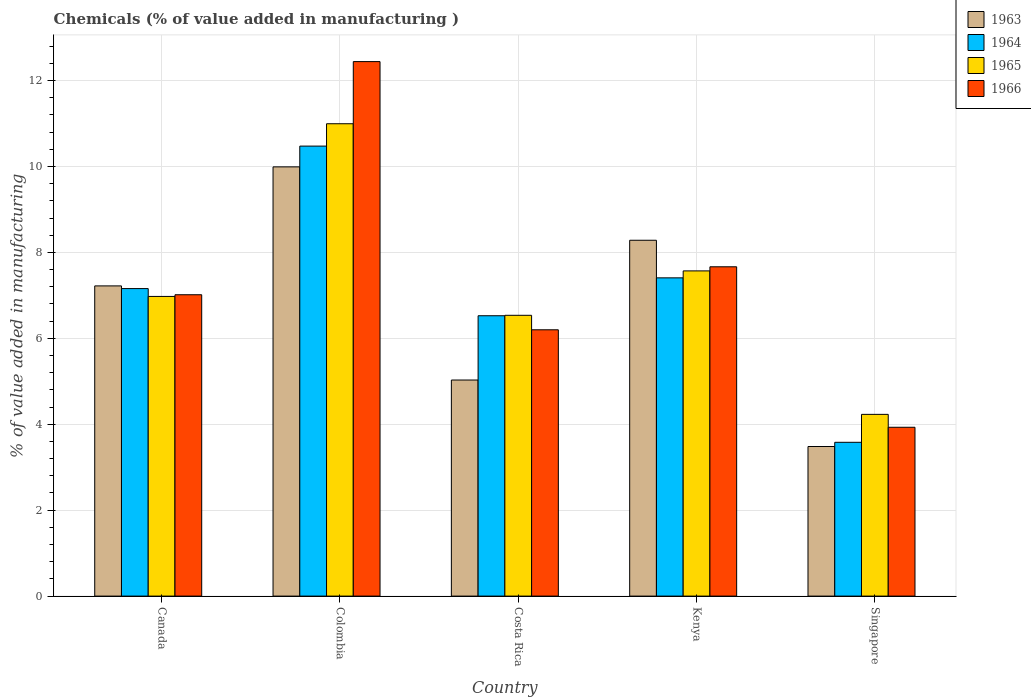Are the number of bars on each tick of the X-axis equal?
Keep it short and to the point. Yes. What is the label of the 1st group of bars from the left?
Your answer should be compact. Canada. What is the value added in manufacturing chemicals in 1964 in Canada?
Provide a succinct answer. 7.16. Across all countries, what is the maximum value added in manufacturing chemicals in 1963?
Give a very brief answer. 9.99. Across all countries, what is the minimum value added in manufacturing chemicals in 1965?
Give a very brief answer. 4.23. In which country was the value added in manufacturing chemicals in 1966 minimum?
Give a very brief answer. Singapore. What is the total value added in manufacturing chemicals in 1963 in the graph?
Ensure brevity in your answer.  34.01. What is the difference between the value added in manufacturing chemicals in 1964 in Costa Rica and that in Kenya?
Your answer should be compact. -0.88. What is the difference between the value added in manufacturing chemicals in 1964 in Colombia and the value added in manufacturing chemicals in 1965 in Singapore?
Your answer should be compact. 6.24. What is the average value added in manufacturing chemicals in 1966 per country?
Give a very brief answer. 7.45. What is the difference between the value added in manufacturing chemicals of/in 1966 and value added in manufacturing chemicals of/in 1963 in Singapore?
Provide a succinct answer. 0.45. What is the ratio of the value added in manufacturing chemicals in 1965 in Canada to that in Singapore?
Keep it short and to the point. 1.65. Is the value added in manufacturing chemicals in 1965 in Costa Rica less than that in Kenya?
Your response must be concise. Yes. What is the difference between the highest and the second highest value added in manufacturing chemicals in 1963?
Offer a very short reply. -1.71. What is the difference between the highest and the lowest value added in manufacturing chemicals in 1965?
Offer a very short reply. 6.76. Is the sum of the value added in manufacturing chemicals in 1963 in Costa Rica and Kenya greater than the maximum value added in manufacturing chemicals in 1966 across all countries?
Your answer should be very brief. Yes. Is it the case that in every country, the sum of the value added in manufacturing chemicals in 1963 and value added in manufacturing chemicals in 1966 is greater than the sum of value added in manufacturing chemicals in 1964 and value added in manufacturing chemicals in 1965?
Offer a terse response. No. What does the 4th bar from the left in Colombia represents?
Provide a succinct answer. 1966. What does the 1st bar from the right in Singapore represents?
Offer a very short reply. 1966. Is it the case that in every country, the sum of the value added in manufacturing chemicals in 1964 and value added in manufacturing chemicals in 1966 is greater than the value added in manufacturing chemicals in 1963?
Your answer should be compact. Yes. How many bars are there?
Offer a very short reply. 20. What is the difference between two consecutive major ticks on the Y-axis?
Provide a short and direct response. 2. Does the graph contain grids?
Offer a very short reply. Yes. How many legend labels are there?
Offer a terse response. 4. What is the title of the graph?
Keep it short and to the point. Chemicals (% of value added in manufacturing ). Does "1996" appear as one of the legend labels in the graph?
Keep it short and to the point. No. What is the label or title of the Y-axis?
Your response must be concise. % of value added in manufacturing. What is the % of value added in manufacturing in 1963 in Canada?
Provide a short and direct response. 7.22. What is the % of value added in manufacturing in 1964 in Canada?
Keep it short and to the point. 7.16. What is the % of value added in manufacturing of 1965 in Canada?
Give a very brief answer. 6.98. What is the % of value added in manufacturing of 1966 in Canada?
Provide a short and direct response. 7.01. What is the % of value added in manufacturing of 1963 in Colombia?
Ensure brevity in your answer.  9.99. What is the % of value added in manufacturing of 1964 in Colombia?
Offer a terse response. 10.47. What is the % of value added in manufacturing in 1965 in Colombia?
Your answer should be compact. 10.99. What is the % of value added in manufacturing of 1966 in Colombia?
Your answer should be compact. 12.44. What is the % of value added in manufacturing of 1963 in Costa Rica?
Ensure brevity in your answer.  5.03. What is the % of value added in manufacturing in 1964 in Costa Rica?
Give a very brief answer. 6.53. What is the % of value added in manufacturing of 1965 in Costa Rica?
Provide a short and direct response. 6.54. What is the % of value added in manufacturing in 1966 in Costa Rica?
Make the answer very short. 6.2. What is the % of value added in manufacturing in 1963 in Kenya?
Your answer should be compact. 8.28. What is the % of value added in manufacturing of 1964 in Kenya?
Your answer should be compact. 7.41. What is the % of value added in manufacturing of 1965 in Kenya?
Keep it short and to the point. 7.57. What is the % of value added in manufacturing in 1966 in Kenya?
Make the answer very short. 7.67. What is the % of value added in manufacturing in 1963 in Singapore?
Keep it short and to the point. 3.48. What is the % of value added in manufacturing of 1964 in Singapore?
Give a very brief answer. 3.58. What is the % of value added in manufacturing in 1965 in Singapore?
Make the answer very short. 4.23. What is the % of value added in manufacturing in 1966 in Singapore?
Offer a terse response. 3.93. Across all countries, what is the maximum % of value added in manufacturing of 1963?
Provide a short and direct response. 9.99. Across all countries, what is the maximum % of value added in manufacturing in 1964?
Make the answer very short. 10.47. Across all countries, what is the maximum % of value added in manufacturing of 1965?
Provide a succinct answer. 10.99. Across all countries, what is the maximum % of value added in manufacturing of 1966?
Offer a terse response. 12.44. Across all countries, what is the minimum % of value added in manufacturing of 1963?
Provide a short and direct response. 3.48. Across all countries, what is the minimum % of value added in manufacturing of 1964?
Offer a terse response. 3.58. Across all countries, what is the minimum % of value added in manufacturing of 1965?
Your response must be concise. 4.23. Across all countries, what is the minimum % of value added in manufacturing in 1966?
Your response must be concise. 3.93. What is the total % of value added in manufacturing in 1963 in the graph?
Provide a short and direct response. 34.01. What is the total % of value added in manufacturing of 1964 in the graph?
Ensure brevity in your answer.  35.15. What is the total % of value added in manufacturing in 1965 in the graph?
Your response must be concise. 36.31. What is the total % of value added in manufacturing in 1966 in the graph?
Offer a terse response. 37.25. What is the difference between the % of value added in manufacturing in 1963 in Canada and that in Colombia?
Ensure brevity in your answer.  -2.77. What is the difference between the % of value added in manufacturing in 1964 in Canada and that in Colombia?
Give a very brief answer. -3.32. What is the difference between the % of value added in manufacturing in 1965 in Canada and that in Colombia?
Offer a terse response. -4.02. What is the difference between the % of value added in manufacturing in 1966 in Canada and that in Colombia?
Keep it short and to the point. -5.43. What is the difference between the % of value added in manufacturing of 1963 in Canada and that in Costa Rica?
Offer a terse response. 2.19. What is the difference between the % of value added in manufacturing in 1964 in Canada and that in Costa Rica?
Keep it short and to the point. 0.63. What is the difference between the % of value added in manufacturing of 1965 in Canada and that in Costa Rica?
Make the answer very short. 0.44. What is the difference between the % of value added in manufacturing in 1966 in Canada and that in Costa Rica?
Your answer should be compact. 0.82. What is the difference between the % of value added in manufacturing of 1963 in Canada and that in Kenya?
Make the answer very short. -1.06. What is the difference between the % of value added in manufacturing in 1964 in Canada and that in Kenya?
Keep it short and to the point. -0.25. What is the difference between the % of value added in manufacturing in 1965 in Canada and that in Kenya?
Offer a terse response. -0.59. What is the difference between the % of value added in manufacturing in 1966 in Canada and that in Kenya?
Your response must be concise. -0.65. What is the difference between the % of value added in manufacturing in 1963 in Canada and that in Singapore?
Provide a succinct answer. 3.74. What is the difference between the % of value added in manufacturing in 1964 in Canada and that in Singapore?
Provide a short and direct response. 3.58. What is the difference between the % of value added in manufacturing in 1965 in Canada and that in Singapore?
Make the answer very short. 2.75. What is the difference between the % of value added in manufacturing of 1966 in Canada and that in Singapore?
Provide a succinct answer. 3.08. What is the difference between the % of value added in manufacturing of 1963 in Colombia and that in Costa Rica?
Provide a succinct answer. 4.96. What is the difference between the % of value added in manufacturing of 1964 in Colombia and that in Costa Rica?
Offer a very short reply. 3.95. What is the difference between the % of value added in manufacturing in 1965 in Colombia and that in Costa Rica?
Your answer should be compact. 4.46. What is the difference between the % of value added in manufacturing in 1966 in Colombia and that in Costa Rica?
Provide a succinct answer. 6.24. What is the difference between the % of value added in manufacturing in 1963 in Colombia and that in Kenya?
Provide a short and direct response. 1.71. What is the difference between the % of value added in manufacturing in 1964 in Colombia and that in Kenya?
Offer a terse response. 3.07. What is the difference between the % of value added in manufacturing of 1965 in Colombia and that in Kenya?
Make the answer very short. 3.43. What is the difference between the % of value added in manufacturing in 1966 in Colombia and that in Kenya?
Make the answer very short. 4.78. What is the difference between the % of value added in manufacturing in 1963 in Colombia and that in Singapore?
Give a very brief answer. 6.51. What is the difference between the % of value added in manufacturing in 1964 in Colombia and that in Singapore?
Your response must be concise. 6.89. What is the difference between the % of value added in manufacturing in 1965 in Colombia and that in Singapore?
Your answer should be compact. 6.76. What is the difference between the % of value added in manufacturing in 1966 in Colombia and that in Singapore?
Make the answer very short. 8.51. What is the difference between the % of value added in manufacturing of 1963 in Costa Rica and that in Kenya?
Give a very brief answer. -3.25. What is the difference between the % of value added in manufacturing in 1964 in Costa Rica and that in Kenya?
Provide a succinct answer. -0.88. What is the difference between the % of value added in manufacturing of 1965 in Costa Rica and that in Kenya?
Your answer should be very brief. -1.03. What is the difference between the % of value added in manufacturing of 1966 in Costa Rica and that in Kenya?
Keep it short and to the point. -1.47. What is the difference between the % of value added in manufacturing in 1963 in Costa Rica and that in Singapore?
Offer a very short reply. 1.55. What is the difference between the % of value added in manufacturing of 1964 in Costa Rica and that in Singapore?
Offer a terse response. 2.95. What is the difference between the % of value added in manufacturing in 1965 in Costa Rica and that in Singapore?
Ensure brevity in your answer.  2.31. What is the difference between the % of value added in manufacturing in 1966 in Costa Rica and that in Singapore?
Keep it short and to the point. 2.27. What is the difference between the % of value added in manufacturing in 1963 in Kenya and that in Singapore?
Keep it short and to the point. 4.8. What is the difference between the % of value added in manufacturing in 1964 in Kenya and that in Singapore?
Make the answer very short. 3.83. What is the difference between the % of value added in manufacturing in 1965 in Kenya and that in Singapore?
Provide a succinct answer. 3.34. What is the difference between the % of value added in manufacturing in 1966 in Kenya and that in Singapore?
Your answer should be very brief. 3.74. What is the difference between the % of value added in manufacturing of 1963 in Canada and the % of value added in manufacturing of 1964 in Colombia?
Your answer should be compact. -3.25. What is the difference between the % of value added in manufacturing in 1963 in Canada and the % of value added in manufacturing in 1965 in Colombia?
Offer a very short reply. -3.77. What is the difference between the % of value added in manufacturing in 1963 in Canada and the % of value added in manufacturing in 1966 in Colombia?
Make the answer very short. -5.22. What is the difference between the % of value added in manufacturing of 1964 in Canada and the % of value added in manufacturing of 1965 in Colombia?
Your response must be concise. -3.84. What is the difference between the % of value added in manufacturing in 1964 in Canada and the % of value added in manufacturing in 1966 in Colombia?
Your response must be concise. -5.28. What is the difference between the % of value added in manufacturing of 1965 in Canada and the % of value added in manufacturing of 1966 in Colombia?
Offer a very short reply. -5.47. What is the difference between the % of value added in manufacturing in 1963 in Canada and the % of value added in manufacturing in 1964 in Costa Rica?
Give a very brief answer. 0.69. What is the difference between the % of value added in manufacturing in 1963 in Canada and the % of value added in manufacturing in 1965 in Costa Rica?
Give a very brief answer. 0.68. What is the difference between the % of value added in manufacturing of 1963 in Canada and the % of value added in manufacturing of 1966 in Costa Rica?
Provide a succinct answer. 1.02. What is the difference between the % of value added in manufacturing of 1964 in Canada and the % of value added in manufacturing of 1965 in Costa Rica?
Your response must be concise. 0.62. What is the difference between the % of value added in manufacturing in 1964 in Canada and the % of value added in manufacturing in 1966 in Costa Rica?
Your response must be concise. 0.96. What is the difference between the % of value added in manufacturing of 1965 in Canada and the % of value added in manufacturing of 1966 in Costa Rica?
Provide a succinct answer. 0.78. What is the difference between the % of value added in manufacturing in 1963 in Canada and the % of value added in manufacturing in 1964 in Kenya?
Keep it short and to the point. -0.19. What is the difference between the % of value added in manufacturing in 1963 in Canada and the % of value added in manufacturing in 1965 in Kenya?
Provide a short and direct response. -0.35. What is the difference between the % of value added in manufacturing in 1963 in Canada and the % of value added in manufacturing in 1966 in Kenya?
Provide a succinct answer. -0.44. What is the difference between the % of value added in manufacturing of 1964 in Canada and the % of value added in manufacturing of 1965 in Kenya?
Keep it short and to the point. -0.41. What is the difference between the % of value added in manufacturing in 1964 in Canada and the % of value added in manufacturing in 1966 in Kenya?
Your response must be concise. -0.51. What is the difference between the % of value added in manufacturing in 1965 in Canada and the % of value added in manufacturing in 1966 in Kenya?
Make the answer very short. -0.69. What is the difference between the % of value added in manufacturing of 1963 in Canada and the % of value added in manufacturing of 1964 in Singapore?
Your answer should be very brief. 3.64. What is the difference between the % of value added in manufacturing in 1963 in Canada and the % of value added in manufacturing in 1965 in Singapore?
Your answer should be compact. 2.99. What is the difference between the % of value added in manufacturing in 1963 in Canada and the % of value added in manufacturing in 1966 in Singapore?
Provide a short and direct response. 3.29. What is the difference between the % of value added in manufacturing in 1964 in Canada and the % of value added in manufacturing in 1965 in Singapore?
Keep it short and to the point. 2.93. What is the difference between the % of value added in manufacturing of 1964 in Canada and the % of value added in manufacturing of 1966 in Singapore?
Your answer should be very brief. 3.23. What is the difference between the % of value added in manufacturing in 1965 in Canada and the % of value added in manufacturing in 1966 in Singapore?
Ensure brevity in your answer.  3.05. What is the difference between the % of value added in manufacturing in 1963 in Colombia and the % of value added in manufacturing in 1964 in Costa Rica?
Give a very brief answer. 3.47. What is the difference between the % of value added in manufacturing in 1963 in Colombia and the % of value added in manufacturing in 1965 in Costa Rica?
Keep it short and to the point. 3.46. What is the difference between the % of value added in manufacturing in 1963 in Colombia and the % of value added in manufacturing in 1966 in Costa Rica?
Give a very brief answer. 3.79. What is the difference between the % of value added in manufacturing of 1964 in Colombia and the % of value added in manufacturing of 1965 in Costa Rica?
Your response must be concise. 3.94. What is the difference between the % of value added in manufacturing of 1964 in Colombia and the % of value added in manufacturing of 1966 in Costa Rica?
Offer a very short reply. 4.28. What is the difference between the % of value added in manufacturing of 1965 in Colombia and the % of value added in manufacturing of 1966 in Costa Rica?
Your answer should be very brief. 4.8. What is the difference between the % of value added in manufacturing of 1963 in Colombia and the % of value added in manufacturing of 1964 in Kenya?
Keep it short and to the point. 2.58. What is the difference between the % of value added in manufacturing of 1963 in Colombia and the % of value added in manufacturing of 1965 in Kenya?
Ensure brevity in your answer.  2.42. What is the difference between the % of value added in manufacturing in 1963 in Colombia and the % of value added in manufacturing in 1966 in Kenya?
Provide a short and direct response. 2.33. What is the difference between the % of value added in manufacturing in 1964 in Colombia and the % of value added in manufacturing in 1965 in Kenya?
Provide a succinct answer. 2.9. What is the difference between the % of value added in manufacturing of 1964 in Colombia and the % of value added in manufacturing of 1966 in Kenya?
Your answer should be very brief. 2.81. What is the difference between the % of value added in manufacturing of 1965 in Colombia and the % of value added in manufacturing of 1966 in Kenya?
Keep it short and to the point. 3.33. What is the difference between the % of value added in manufacturing in 1963 in Colombia and the % of value added in manufacturing in 1964 in Singapore?
Your answer should be very brief. 6.41. What is the difference between the % of value added in manufacturing of 1963 in Colombia and the % of value added in manufacturing of 1965 in Singapore?
Offer a terse response. 5.76. What is the difference between the % of value added in manufacturing in 1963 in Colombia and the % of value added in manufacturing in 1966 in Singapore?
Your response must be concise. 6.06. What is the difference between the % of value added in manufacturing in 1964 in Colombia and the % of value added in manufacturing in 1965 in Singapore?
Make the answer very short. 6.24. What is the difference between the % of value added in manufacturing in 1964 in Colombia and the % of value added in manufacturing in 1966 in Singapore?
Provide a short and direct response. 6.54. What is the difference between the % of value added in manufacturing of 1965 in Colombia and the % of value added in manufacturing of 1966 in Singapore?
Give a very brief answer. 7.07. What is the difference between the % of value added in manufacturing of 1963 in Costa Rica and the % of value added in manufacturing of 1964 in Kenya?
Provide a succinct answer. -2.38. What is the difference between the % of value added in manufacturing of 1963 in Costa Rica and the % of value added in manufacturing of 1965 in Kenya?
Offer a terse response. -2.54. What is the difference between the % of value added in manufacturing of 1963 in Costa Rica and the % of value added in manufacturing of 1966 in Kenya?
Provide a short and direct response. -2.64. What is the difference between the % of value added in manufacturing of 1964 in Costa Rica and the % of value added in manufacturing of 1965 in Kenya?
Provide a short and direct response. -1.04. What is the difference between the % of value added in manufacturing of 1964 in Costa Rica and the % of value added in manufacturing of 1966 in Kenya?
Offer a very short reply. -1.14. What is the difference between the % of value added in manufacturing of 1965 in Costa Rica and the % of value added in manufacturing of 1966 in Kenya?
Give a very brief answer. -1.13. What is the difference between the % of value added in manufacturing in 1963 in Costa Rica and the % of value added in manufacturing in 1964 in Singapore?
Give a very brief answer. 1.45. What is the difference between the % of value added in manufacturing of 1963 in Costa Rica and the % of value added in manufacturing of 1965 in Singapore?
Your answer should be compact. 0.8. What is the difference between the % of value added in manufacturing in 1963 in Costa Rica and the % of value added in manufacturing in 1966 in Singapore?
Keep it short and to the point. 1.1. What is the difference between the % of value added in manufacturing in 1964 in Costa Rica and the % of value added in manufacturing in 1965 in Singapore?
Offer a very short reply. 2.3. What is the difference between the % of value added in manufacturing in 1964 in Costa Rica and the % of value added in manufacturing in 1966 in Singapore?
Provide a short and direct response. 2.6. What is the difference between the % of value added in manufacturing in 1965 in Costa Rica and the % of value added in manufacturing in 1966 in Singapore?
Give a very brief answer. 2.61. What is the difference between the % of value added in manufacturing of 1963 in Kenya and the % of value added in manufacturing of 1964 in Singapore?
Offer a terse response. 4.7. What is the difference between the % of value added in manufacturing of 1963 in Kenya and the % of value added in manufacturing of 1965 in Singapore?
Offer a terse response. 4.05. What is the difference between the % of value added in manufacturing in 1963 in Kenya and the % of value added in manufacturing in 1966 in Singapore?
Provide a succinct answer. 4.35. What is the difference between the % of value added in manufacturing of 1964 in Kenya and the % of value added in manufacturing of 1965 in Singapore?
Make the answer very short. 3.18. What is the difference between the % of value added in manufacturing of 1964 in Kenya and the % of value added in manufacturing of 1966 in Singapore?
Make the answer very short. 3.48. What is the difference between the % of value added in manufacturing of 1965 in Kenya and the % of value added in manufacturing of 1966 in Singapore?
Make the answer very short. 3.64. What is the average % of value added in manufacturing of 1963 per country?
Your response must be concise. 6.8. What is the average % of value added in manufacturing in 1964 per country?
Offer a terse response. 7.03. What is the average % of value added in manufacturing in 1965 per country?
Provide a succinct answer. 7.26. What is the average % of value added in manufacturing in 1966 per country?
Offer a terse response. 7.45. What is the difference between the % of value added in manufacturing of 1963 and % of value added in manufacturing of 1964 in Canada?
Offer a terse response. 0.06. What is the difference between the % of value added in manufacturing of 1963 and % of value added in manufacturing of 1965 in Canada?
Offer a terse response. 0.25. What is the difference between the % of value added in manufacturing of 1963 and % of value added in manufacturing of 1966 in Canada?
Keep it short and to the point. 0.21. What is the difference between the % of value added in manufacturing of 1964 and % of value added in manufacturing of 1965 in Canada?
Offer a very short reply. 0.18. What is the difference between the % of value added in manufacturing in 1964 and % of value added in manufacturing in 1966 in Canada?
Your response must be concise. 0.14. What is the difference between the % of value added in manufacturing of 1965 and % of value added in manufacturing of 1966 in Canada?
Give a very brief answer. -0.04. What is the difference between the % of value added in manufacturing of 1963 and % of value added in manufacturing of 1964 in Colombia?
Give a very brief answer. -0.48. What is the difference between the % of value added in manufacturing of 1963 and % of value added in manufacturing of 1965 in Colombia?
Your response must be concise. -1. What is the difference between the % of value added in manufacturing of 1963 and % of value added in manufacturing of 1966 in Colombia?
Provide a succinct answer. -2.45. What is the difference between the % of value added in manufacturing in 1964 and % of value added in manufacturing in 1965 in Colombia?
Make the answer very short. -0.52. What is the difference between the % of value added in manufacturing in 1964 and % of value added in manufacturing in 1966 in Colombia?
Your answer should be compact. -1.97. What is the difference between the % of value added in manufacturing of 1965 and % of value added in manufacturing of 1966 in Colombia?
Provide a succinct answer. -1.45. What is the difference between the % of value added in manufacturing of 1963 and % of value added in manufacturing of 1964 in Costa Rica?
Give a very brief answer. -1.5. What is the difference between the % of value added in manufacturing in 1963 and % of value added in manufacturing in 1965 in Costa Rica?
Your response must be concise. -1.51. What is the difference between the % of value added in manufacturing of 1963 and % of value added in manufacturing of 1966 in Costa Rica?
Offer a terse response. -1.17. What is the difference between the % of value added in manufacturing in 1964 and % of value added in manufacturing in 1965 in Costa Rica?
Keep it short and to the point. -0.01. What is the difference between the % of value added in manufacturing in 1964 and % of value added in manufacturing in 1966 in Costa Rica?
Your answer should be very brief. 0.33. What is the difference between the % of value added in manufacturing in 1965 and % of value added in manufacturing in 1966 in Costa Rica?
Offer a terse response. 0.34. What is the difference between the % of value added in manufacturing in 1963 and % of value added in manufacturing in 1964 in Kenya?
Ensure brevity in your answer.  0.87. What is the difference between the % of value added in manufacturing of 1963 and % of value added in manufacturing of 1965 in Kenya?
Your answer should be very brief. 0.71. What is the difference between the % of value added in manufacturing in 1963 and % of value added in manufacturing in 1966 in Kenya?
Your answer should be very brief. 0.62. What is the difference between the % of value added in manufacturing of 1964 and % of value added in manufacturing of 1965 in Kenya?
Make the answer very short. -0.16. What is the difference between the % of value added in manufacturing of 1964 and % of value added in manufacturing of 1966 in Kenya?
Keep it short and to the point. -0.26. What is the difference between the % of value added in manufacturing of 1965 and % of value added in manufacturing of 1966 in Kenya?
Provide a succinct answer. -0.1. What is the difference between the % of value added in manufacturing in 1963 and % of value added in manufacturing in 1964 in Singapore?
Offer a terse response. -0.1. What is the difference between the % of value added in manufacturing in 1963 and % of value added in manufacturing in 1965 in Singapore?
Your answer should be very brief. -0.75. What is the difference between the % of value added in manufacturing of 1963 and % of value added in manufacturing of 1966 in Singapore?
Make the answer very short. -0.45. What is the difference between the % of value added in manufacturing of 1964 and % of value added in manufacturing of 1965 in Singapore?
Your answer should be compact. -0.65. What is the difference between the % of value added in manufacturing in 1964 and % of value added in manufacturing in 1966 in Singapore?
Keep it short and to the point. -0.35. What is the difference between the % of value added in manufacturing of 1965 and % of value added in manufacturing of 1966 in Singapore?
Your response must be concise. 0.3. What is the ratio of the % of value added in manufacturing in 1963 in Canada to that in Colombia?
Offer a terse response. 0.72. What is the ratio of the % of value added in manufacturing of 1964 in Canada to that in Colombia?
Offer a very short reply. 0.68. What is the ratio of the % of value added in manufacturing in 1965 in Canada to that in Colombia?
Offer a terse response. 0.63. What is the ratio of the % of value added in manufacturing in 1966 in Canada to that in Colombia?
Keep it short and to the point. 0.56. What is the ratio of the % of value added in manufacturing of 1963 in Canada to that in Costa Rica?
Offer a terse response. 1.44. What is the ratio of the % of value added in manufacturing of 1964 in Canada to that in Costa Rica?
Ensure brevity in your answer.  1.1. What is the ratio of the % of value added in manufacturing of 1965 in Canada to that in Costa Rica?
Your answer should be very brief. 1.07. What is the ratio of the % of value added in manufacturing of 1966 in Canada to that in Costa Rica?
Make the answer very short. 1.13. What is the ratio of the % of value added in manufacturing of 1963 in Canada to that in Kenya?
Offer a very short reply. 0.87. What is the ratio of the % of value added in manufacturing of 1964 in Canada to that in Kenya?
Make the answer very short. 0.97. What is the ratio of the % of value added in manufacturing of 1965 in Canada to that in Kenya?
Offer a terse response. 0.92. What is the ratio of the % of value added in manufacturing in 1966 in Canada to that in Kenya?
Provide a succinct answer. 0.92. What is the ratio of the % of value added in manufacturing of 1963 in Canada to that in Singapore?
Your response must be concise. 2.07. What is the ratio of the % of value added in manufacturing in 1964 in Canada to that in Singapore?
Your response must be concise. 2. What is the ratio of the % of value added in manufacturing in 1965 in Canada to that in Singapore?
Offer a very short reply. 1.65. What is the ratio of the % of value added in manufacturing of 1966 in Canada to that in Singapore?
Give a very brief answer. 1.78. What is the ratio of the % of value added in manufacturing in 1963 in Colombia to that in Costa Rica?
Offer a terse response. 1.99. What is the ratio of the % of value added in manufacturing in 1964 in Colombia to that in Costa Rica?
Offer a very short reply. 1.61. What is the ratio of the % of value added in manufacturing in 1965 in Colombia to that in Costa Rica?
Give a very brief answer. 1.68. What is the ratio of the % of value added in manufacturing of 1966 in Colombia to that in Costa Rica?
Ensure brevity in your answer.  2.01. What is the ratio of the % of value added in manufacturing in 1963 in Colombia to that in Kenya?
Give a very brief answer. 1.21. What is the ratio of the % of value added in manufacturing in 1964 in Colombia to that in Kenya?
Offer a very short reply. 1.41. What is the ratio of the % of value added in manufacturing in 1965 in Colombia to that in Kenya?
Your answer should be compact. 1.45. What is the ratio of the % of value added in manufacturing in 1966 in Colombia to that in Kenya?
Offer a terse response. 1.62. What is the ratio of the % of value added in manufacturing of 1963 in Colombia to that in Singapore?
Your answer should be very brief. 2.87. What is the ratio of the % of value added in manufacturing in 1964 in Colombia to that in Singapore?
Give a very brief answer. 2.93. What is the ratio of the % of value added in manufacturing of 1965 in Colombia to that in Singapore?
Keep it short and to the point. 2.6. What is the ratio of the % of value added in manufacturing in 1966 in Colombia to that in Singapore?
Keep it short and to the point. 3.17. What is the ratio of the % of value added in manufacturing of 1963 in Costa Rica to that in Kenya?
Your answer should be very brief. 0.61. What is the ratio of the % of value added in manufacturing of 1964 in Costa Rica to that in Kenya?
Your answer should be very brief. 0.88. What is the ratio of the % of value added in manufacturing of 1965 in Costa Rica to that in Kenya?
Your answer should be compact. 0.86. What is the ratio of the % of value added in manufacturing of 1966 in Costa Rica to that in Kenya?
Offer a very short reply. 0.81. What is the ratio of the % of value added in manufacturing in 1963 in Costa Rica to that in Singapore?
Provide a short and direct response. 1.44. What is the ratio of the % of value added in manufacturing in 1964 in Costa Rica to that in Singapore?
Make the answer very short. 1.82. What is the ratio of the % of value added in manufacturing of 1965 in Costa Rica to that in Singapore?
Offer a terse response. 1.55. What is the ratio of the % of value added in manufacturing of 1966 in Costa Rica to that in Singapore?
Offer a very short reply. 1.58. What is the ratio of the % of value added in manufacturing in 1963 in Kenya to that in Singapore?
Your answer should be compact. 2.38. What is the ratio of the % of value added in manufacturing of 1964 in Kenya to that in Singapore?
Provide a succinct answer. 2.07. What is the ratio of the % of value added in manufacturing in 1965 in Kenya to that in Singapore?
Make the answer very short. 1.79. What is the ratio of the % of value added in manufacturing of 1966 in Kenya to that in Singapore?
Your answer should be very brief. 1.95. What is the difference between the highest and the second highest % of value added in manufacturing of 1963?
Your response must be concise. 1.71. What is the difference between the highest and the second highest % of value added in manufacturing in 1964?
Provide a short and direct response. 3.07. What is the difference between the highest and the second highest % of value added in manufacturing in 1965?
Your answer should be very brief. 3.43. What is the difference between the highest and the second highest % of value added in manufacturing in 1966?
Offer a terse response. 4.78. What is the difference between the highest and the lowest % of value added in manufacturing of 1963?
Make the answer very short. 6.51. What is the difference between the highest and the lowest % of value added in manufacturing of 1964?
Your answer should be compact. 6.89. What is the difference between the highest and the lowest % of value added in manufacturing in 1965?
Give a very brief answer. 6.76. What is the difference between the highest and the lowest % of value added in manufacturing of 1966?
Make the answer very short. 8.51. 